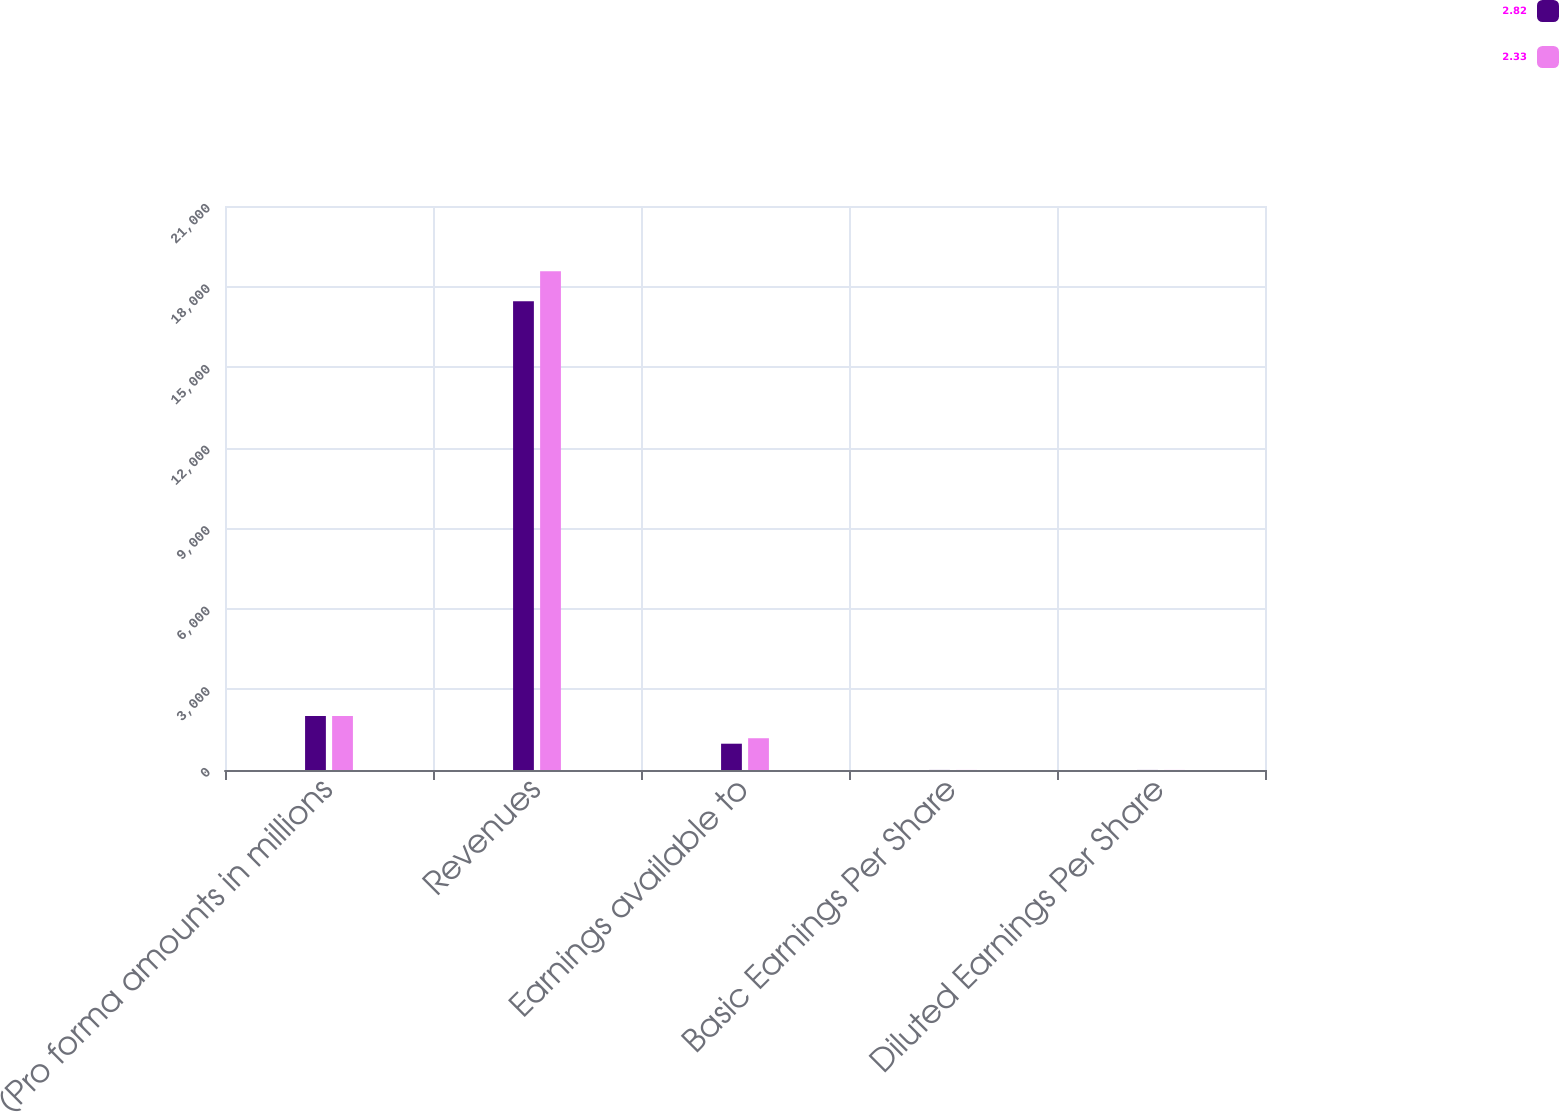Convert chart. <chart><loc_0><loc_0><loc_500><loc_500><stacked_bar_chart><ecel><fcel>(Pro forma amounts in millions<fcel>Revenues<fcel>Earnings available to<fcel>Basic Earnings Per Share<fcel>Diluted Earnings Per Share<nl><fcel>2.82<fcel>2011<fcel>17449<fcel>979<fcel>2.34<fcel>2.33<nl><fcel>2.33<fcel>2010<fcel>18569<fcel>1183<fcel>2.83<fcel>2.82<nl></chart> 